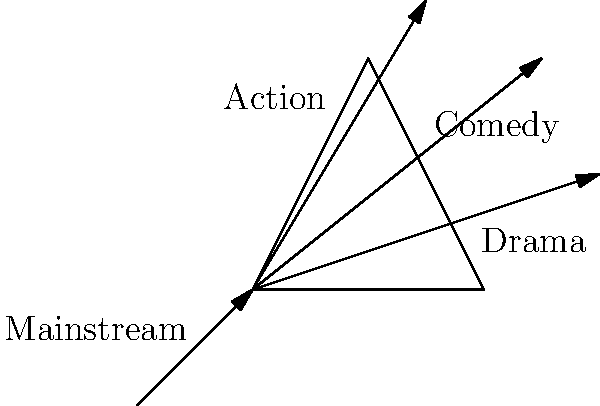In the context of streaming platform diversity, consider the prism diagram representing various genres. If "Mainstream" content enters the prism, which genre is likely to experience the least deviation (or "refraction") from the original content, maintaining the closest alignment with traditional mainstream offerings? To answer this question, we need to consider the concept of refraction in optics and apply it metaphorically to content diversification in streaming platforms:

1. In optics, refraction occurs when light passes from one medium to another, changing its direction.
2. The amount of refraction depends on the difference in refractive indices between the two media.
3. In our metaphor, the "Mainstream" content entering the prism represents traditional content.
4. The different genres (Drama, Comedy, Action) represent how this content can be diversified.
5. The degree of "refraction" or deviation from the original path represents how much each genre diverges from traditional mainstream content.
6. Looking at the diagram:
   - The "Drama" ray deviates the least from the original path of the "Mainstream" ray.
   - "Comedy" shows a moderate deviation.
   - "Action" shows the greatest deviation.
7. In the context of streaming platforms, drama often retains many elements of traditional storytelling and themes, even when diversified.
8. Comedy and action genres typically involve more significant departures from mainstream conventions when diversity is introduced.

Therefore, the genre experiencing the least deviation from traditional mainstream content is Drama.
Answer: Drama 